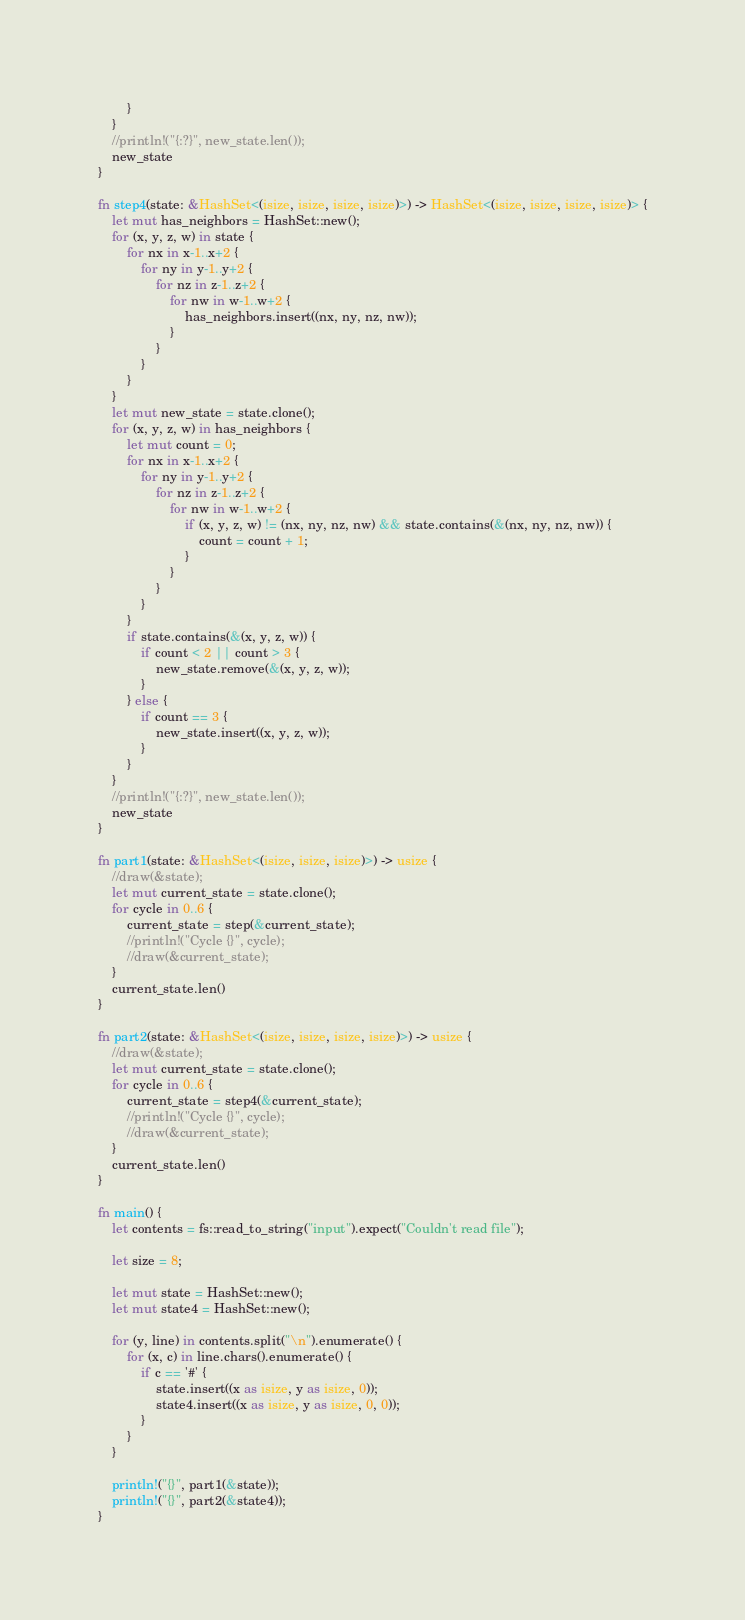Convert code to text. <code><loc_0><loc_0><loc_500><loc_500><_Rust_>		}
	}
	//println!("{:?}", new_state.len());
	new_state
}

fn step4(state: &HashSet<(isize, isize, isize, isize)>) -> HashSet<(isize, isize, isize, isize)> {
	let mut has_neighbors = HashSet::new();
	for (x, y, z, w) in state {
		for nx in x-1..x+2 {
			for ny in y-1..y+2 {
				for nz in z-1..z+2 {
					for nw in w-1..w+2 {
						has_neighbors.insert((nx, ny, nz, nw));
					}
				}
			}
		}
	}
	let mut new_state = state.clone();
	for (x, y, z, w) in has_neighbors {
		let mut count = 0;
		for nx in x-1..x+2 {
			for ny in y-1..y+2 {
				for nz in z-1..z+2 {
					for nw in w-1..w+2 {
						if (x, y, z, w) != (nx, ny, nz, nw) && state.contains(&(nx, ny, nz, nw)) {
							count = count + 1;
						}
					}
				}
			}
		}
		if state.contains(&(x, y, z, w)) {
			if count < 2 || count > 3 {
				new_state.remove(&(x, y, z, w));
			}
		} else {
			if count == 3 {
				new_state.insert((x, y, z, w));
			}
		}
	}
	//println!("{:?}", new_state.len());
	new_state
}

fn part1(state: &HashSet<(isize, isize, isize)>) -> usize {
	//draw(&state);
	let mut current_state = state.clone();
	for cycle in 0..6 {
		current_state = step(&current_state);
		//println!("Cycle {}", cycle);
		//draw(&current_state);
	}
	current_state.len()
}

fn part2(state: &HashSet<(isize, isize, isize, isize)>) -> usize {
	//draw(&state);
	let mut current_state = state.clone();
	for cycle in 0..6 {
		current_state = step4(&current_state);
		//println!("Cycle {}", cycle);
		//draw(&current_state);
	}
	current_state.len()
}

fn main() {
    let contents = fs::read_to_string("input").expect("Couldn't read file");

    let size = 8;

    let mut state = HashSet::new();
    let mut state4 = HashSet::new();

    for (y, line) in contents.split("\n").enumerate() {
    	for (x, c) in line.chars().enumerate() {
    		if c == '#' {
    			state.insert((x as isize, y as isize, 0));
    			state4.insert((x as isize, y as isize, 0, 0));
    		}
    	}
    }

    println!("{}", part1(&state));
    println!("{}", part2(&state4));
}
</code> 